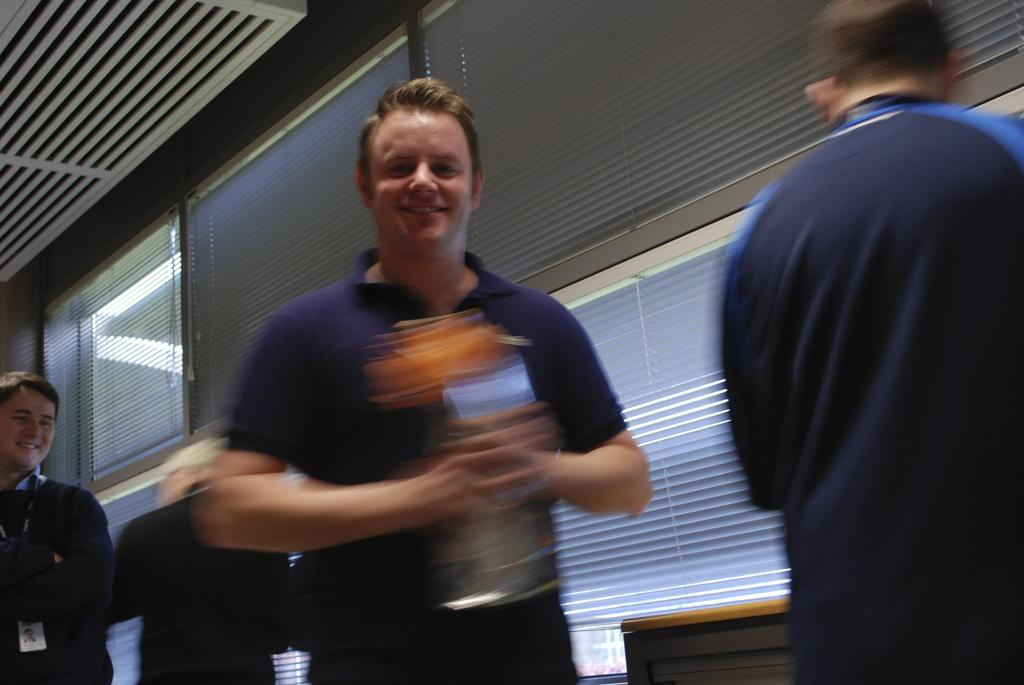What is the person in the image holding? The person is holding something in the image, but the facts do not specify what it is. What is the facial expression of the person in the image? The person is smiling in the image. What can be seen in the background of the image? There are other people in the background of the image, and they are standing near a table. What type of windows are visible in the background of the image? There are glass windows in the background of the image. What type of music can be heard coming from the plane in the image? There is no plane present in the image, so it is not possible to determine what type of music might be heard. 